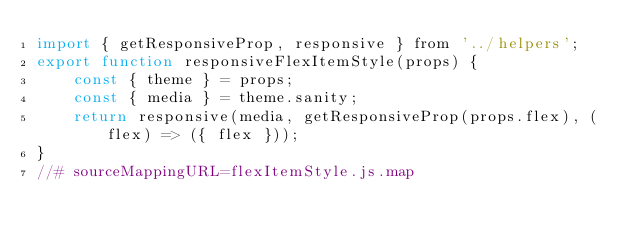<code> <loc_0><loc_0><loc_500><loc_500><_JavaScript_>import { getResponsiveProp, responsive } from '../helpers';
export function responsiveFlexItemStyle(props) {
    const { theme } = props;
    const { media } = theme.sanity;
    return responsive(media, getResponsiveProp(props.flex), (flex) => ({ flex }));
}
//# sourceMappingURL=flexItemStyle.js.map</code> 